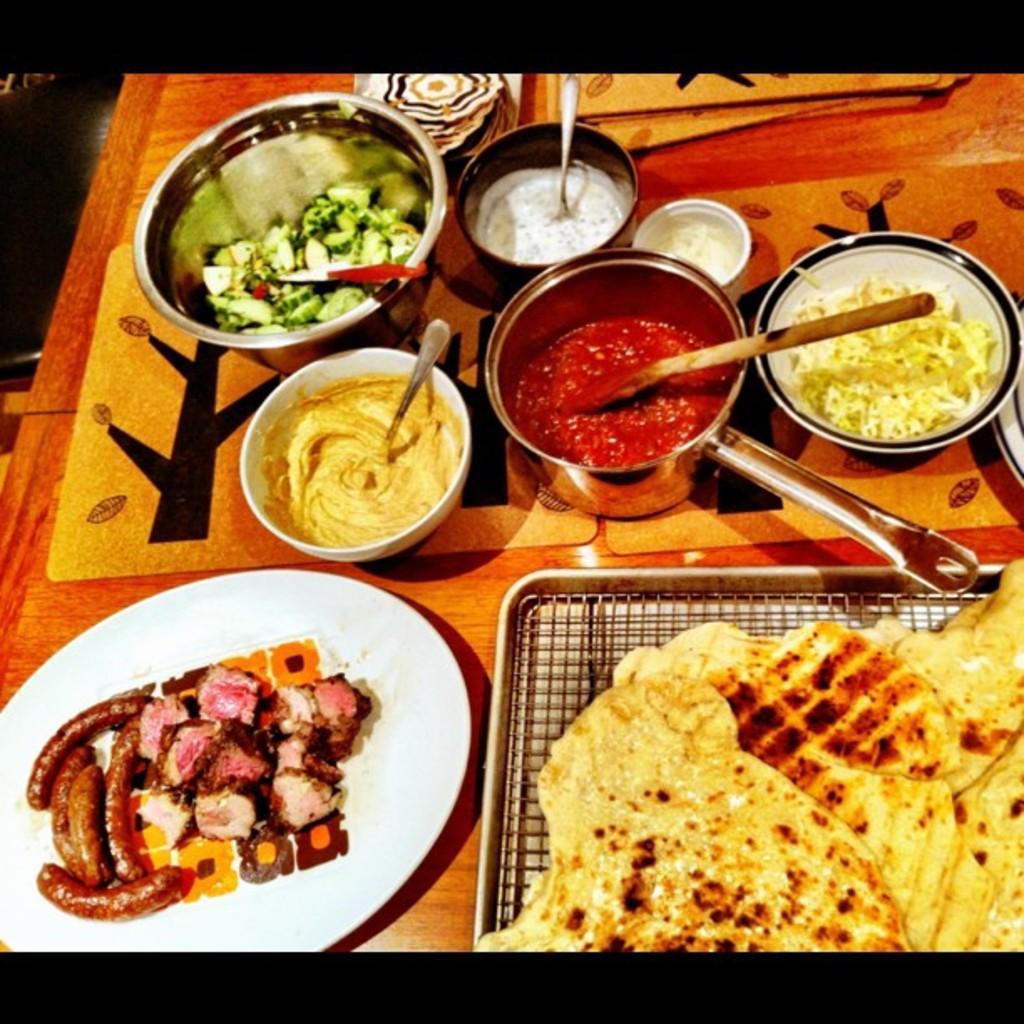Can you describe this image briefly? In this picture we can see food in the bowls and plates, and also we can see spoons. 